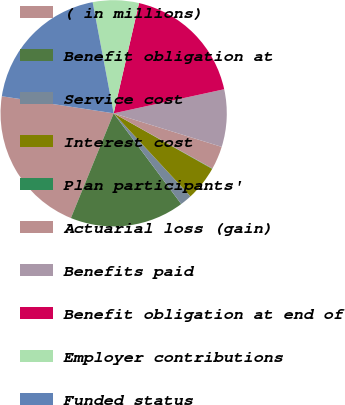Convert chart. <chart><loc_0><loc_0><loc_500><loc_500><pie_chart><fcel>( in millions)<fcel>Benefit obligation at<fcel>Service cost<fcel>Interest cost<fcel>Plan participants'<fcel>Actuarial loss (gain)<fcel>Benefits paid<fcel>Benefit obligation at end of<fcel>Employer contributions<fcel>Funded status<nl><fcel>21.25%<fcel>16.36%<fcel>1.69%<fcel>4.95%<fcel>0.06%<fcel>3.32%<fcel>8.21%<fcel>17.99%<fcel>6.58%<fcel>19.62%<nl></chart> 